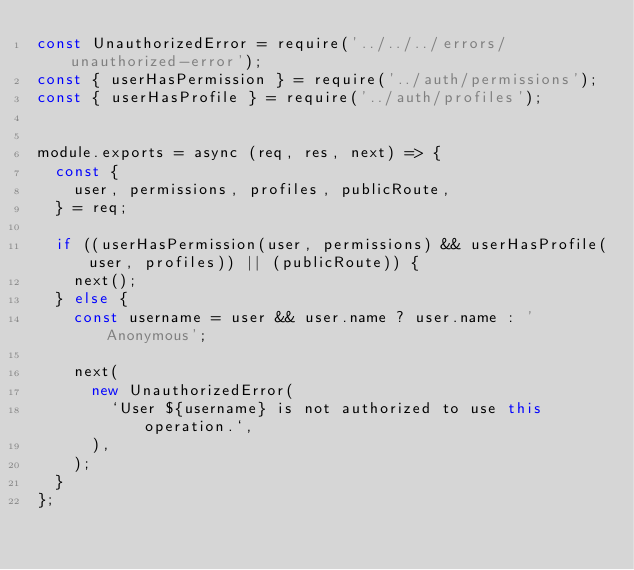Convert code to text. <code><loc_0><loc_0><loc_500><loc_500><_JavaScript_>const UnauthorizedError = require('../../../errors/unauthorized-error');
const { userHasPermission } = require('../auth/permissions');
const { userHasProfile } = require('../auth/profiles');


module.exports = async (req, res, next) => {
  const {
    user, permissions, profiles, publicRoute,
  } = req;

  if ((userHasPermission(user, permissions) && userHasProfile(user, profiles)) || (publicRoute)) {
    next();
  } else {
    const username = user && user.name ? user.name : 'Anonymous';

    next(
      new UnauthorizedError(
        `User ${username} is not authorized to use this operation.`,
      ),
    );
  }
};
</code> 